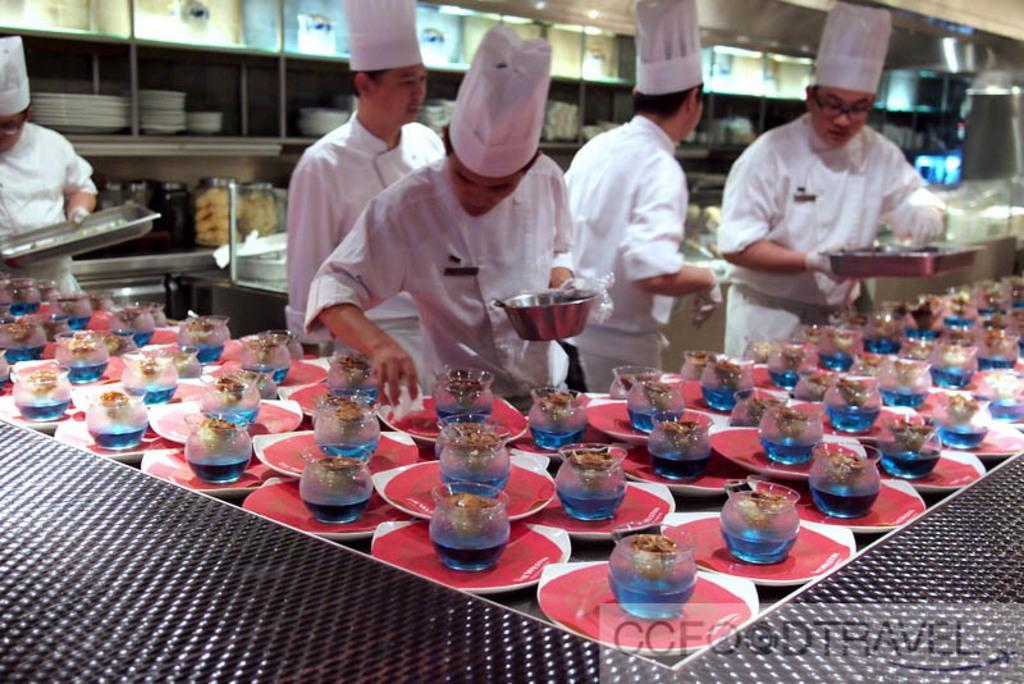In one or two sentences, can you explain what this image depicts? There are group of people standing. Three men are holding trays and a bowl. This is the table with plates and glass jars on it. I think this picture was taken in the kitchen. These are the plates and glass jars, which are arranged in the rack. I can see the watermark on the image. 